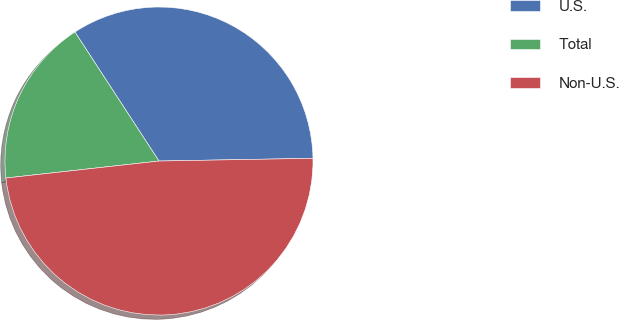<chart> <loc_0><loc_0><loc_500><loc_500><pie_chart><fcel>U.S.<fcel>Total<fcel>Non-U.S.<nl><fcel>33.91%<fcel>17.57%<fcel>48.52%<nl></chart> 